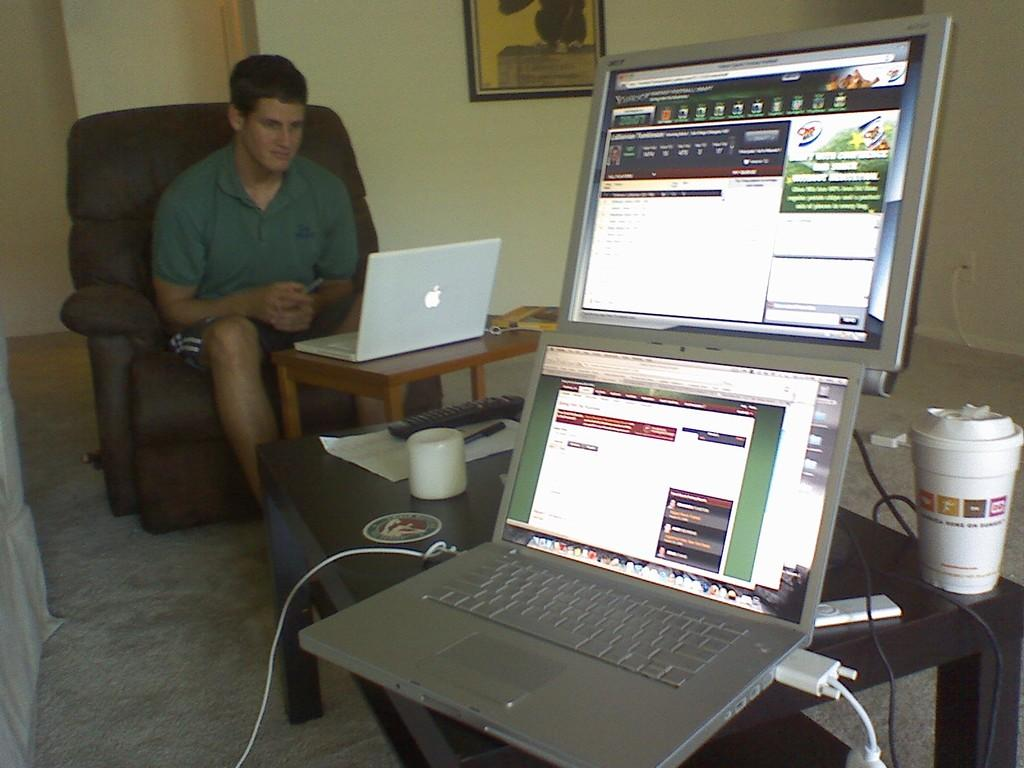What is the person in the image doing? The person is sitting on a chair. What objects can be seen on the table in the image? There are laptops, a glass, a paper, a pen, and a remote on the table. What is present on the wall in the background? There is a frame on the wall. What type of surface is the person sitting on? This is the floor. What does the taste of the sugar in the image reveal about the person's preferences? There is no sugar present in the image, so it is not possible to determine the person's preferences based on taste. 